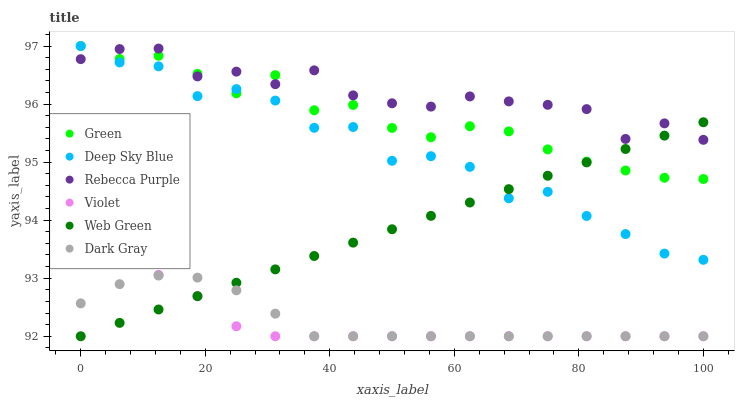Does Violet have the minimum area under the curve?
Answer yes or no. Yes. Does Rebecca Purple have the maximum area under the curve?
Answer yes or no. Yes. Does Dark Gray have the minimum area under the curve?
Answer yes or no. No. Does Dark Gray have the maximum area under the curve?
Answer yes or no. No. Is Web Green the smoothest?
Answer yes or no. Yes. Is Deep Sky Blue the roughest?
Answer yes or no. Yes. Is Dark Gray the smoothest?
Answer yes or no. No. Is Dark Gray the roughest?
Answer yes or no. No. Does Web Green have the lowest value?
Answer yes or no. Yes. Does Green have the lowest value?
Answer yes or no. No. Does Deep Sky Blue have the highest value?
Answer yes or no. Yes. Does Dark Gray have the highest value?
Answer yes or no. No. Is Violet less than Deep Sky Blue?
Answer yes or no. Yes. Is Deep Sky Blue greater than Dark Gray?
Answer yes or no. Yes. Does Green intersect Web Green?
Answer yes or no. Yes. Is Green less than Web Green?
Answer yes or no. No. Is Green greater than Web Green?
Answer yes or no. No. Does Violet intersect Deep Sky Blue?
Answer yes or no. No. 